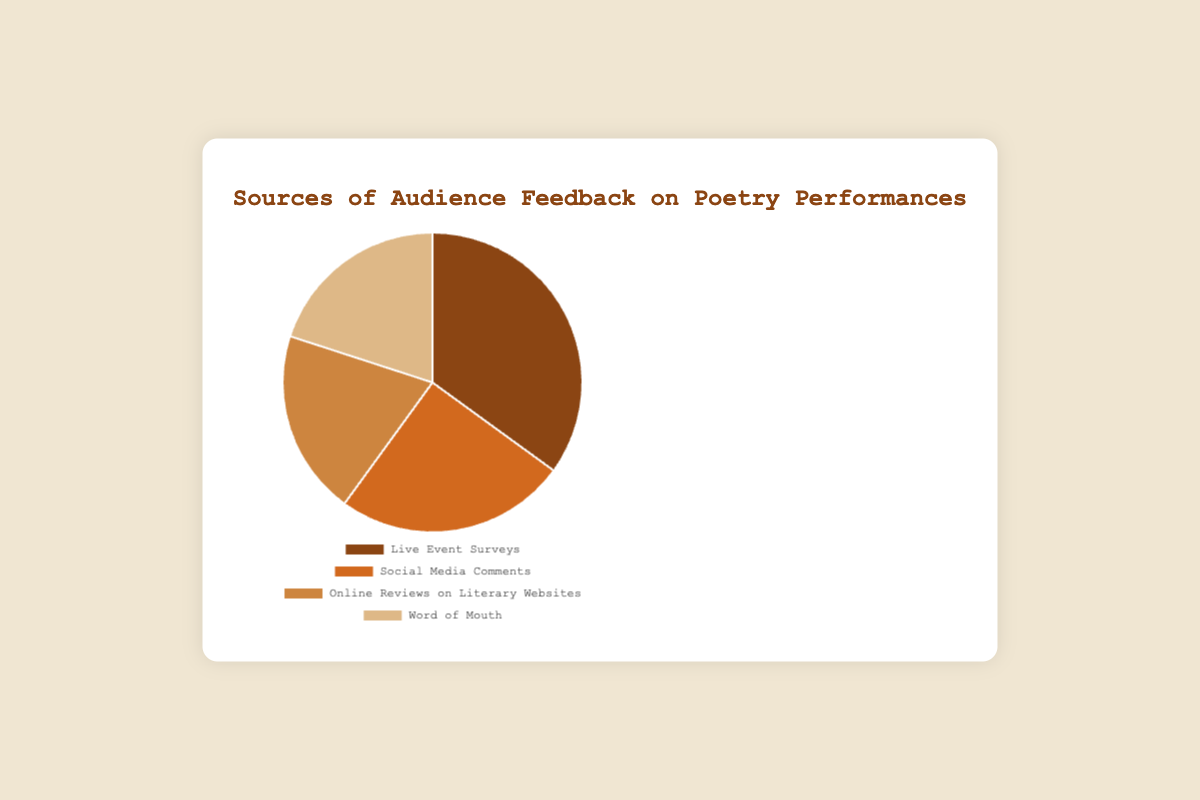What is the largest source of audience feedback on poetry performances? The figure shows four sources of audience feedback. "Live Event Surveys" has the largest portion, making up 35% of the total feedback.
Answer: Live Event Surveys Which two sources of feedback have an equal percentage? The figure indicates that "Online Reviews on Literary Websites" and "Word of Mouth" each constitute 20% of the total feedback, which are equal.
Answer: Online Reviews on Literary Websites and Word of Mouth How much more feedback do Live Event Surveys receive compared to Social Media Comments? According to the figure, Live Event Surveys account for 35% of feedback, while Social Media Comments make up 25%. The difference is calculated by subtracting 25% from 35%, resulting in 10% more feedback from Live Event Surveys.
Answer: 10% What is the combined percentage of feedback from Social Media Comments and Word of Mouth? The figure shows that Social Media Comments constitute 25% and Word of Mouth makes up 20%. Adding these values together gives 25% + 20% = 45%.
Answer: 45% Which source of feedback is represented by the darkest color in the pie chart? The figure uses different shades of brown. The darkest color is used for "Live Event Surveys," which accounts for 35% of feedback.
Answer: Live Event Surveys How does the percentage of feedback from Online Reviews on Literary Websites compare to that from Social Media Comments? The figure shows that Online Reviews on Literary Websites account for 20% of feedback, while Social Media Comments make up 25%. Therefore, Social Media Comments have a 5% higher percentage compared to Online Reviews on Literary Websites.
Answer: Social Media Comments have 5% more Calculate the average percentage of feedback from all four sources. The percentages given are 35%, 25%, 20%, and 20%. To find the average: (35 + 25 + 20 + 20) / 4 = 100 / 4 = 25%.
Answer: 25% If feedback from Live Event Surveys is doubled, what would be its new percentage? Currently, Live Event Surveys account for 35%. Doubling this value: 35% * 2 = 70%.
Answer: 70% What fraction of the total feedback is obtained from Online Reviews on Literary Websites? The figure shows Online Reviews on Literary Websites account for 20% of the feedback. Expressing 20% as a fraction: 20/100 = 1/5.
Answer: 1/5 